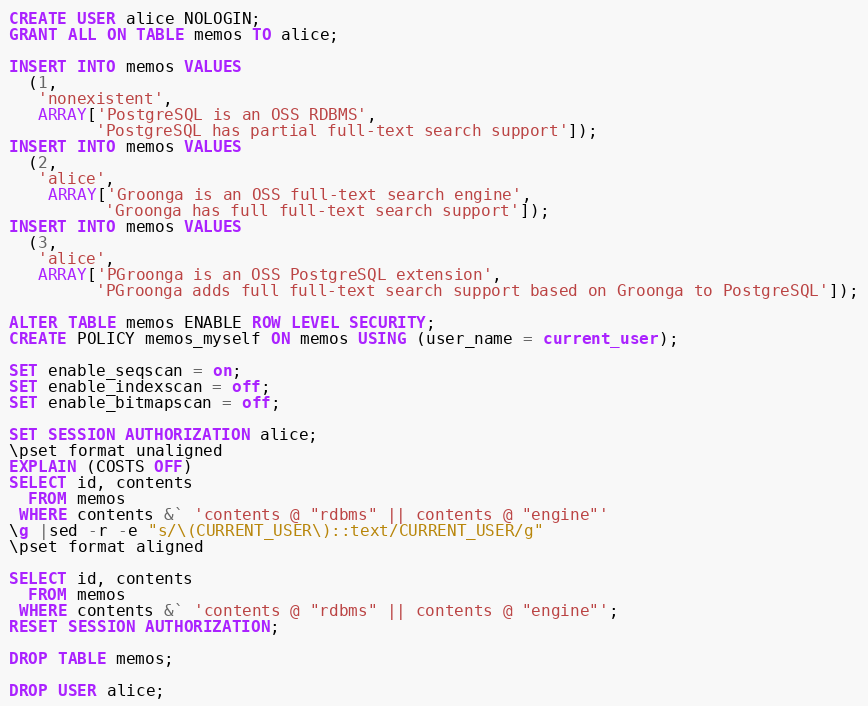Convert code to text. <code><loc_0><loc_0><loc_500><loc_500><_SQL_>CREATE USER alice NOLOGIN;
GRANT ALL ON TABLE memos TO alice;

INSERT INTO memos VALUES
  (1,
   'nonexistent',
   ARRAY['PostgreSQL is an OSS RDBMS',
         'PostgreSQL has partial full-text search support']);
INSERT INTO memos VALUES
  (2,
   'alice',
    ARRAY['Groonga is an OSS full-text search engine',
          'Groonga has full full-text search support']);
INSERT INTO memos VALUES
  (3,
   'alice',
   ARRAY['PGroonga is an OSS PostgreSQL extension',
         'PGroonga adds full full-text search support based on Groonga to PostgreSQL']);

ALTER TABLE memos ENABLE ROW LEVEL SECURITY;
CREATE POLICY memos_myself ON memos USING (user_name = current_user);

SET enable_seqscan = on;
SET enable_indexscan = off;
SET enable_bitmapscan = off;

SET SESSION AUTHORIZATION alice;
\pset format unaligned
EXPLAIN (COSTS OFF)
SELECT id, contents
  FROM memos
 WHERE contents &` 'contents @ "rdbms" || contents @ "engine"'
\g |sed -r -e "s/\(CURRENT_USER\)::text/CURRENT_USER/g"
\pset format aligned

SELECT id, contents
  FROM memos
 WHERE contents &` 'contents @ "rdbms" || contents @ "engine"';
RESET SESSION AUTHORIZATION;

DROP TABLE memos;

DROP USER alice;
</code> 